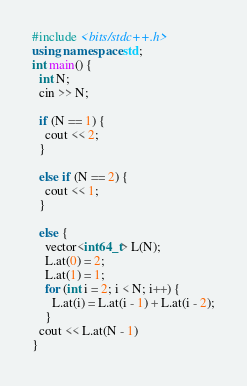Convert code to text. <code><loc_0><loc_0><loc_500><loc_500><_C++_>#include <bits/stdc++.h>
using namespace std;
int main() {
  int N;
  cin >> N;
 
  if (N == 1) {
    cout << 2;
  }
  
  else if (N == 2) {
    cout << 1;
  }
    
  else {
    vector<int64_t> L(N);
    L.at(0) = 2;
    L.at(1) = 1;
    for (int i = 2; i < N; i++) {
      L.at(i) = L.at(i - 1) + L.at(i - 2);
    }
  cout << L.at(N - 1)
}
</code> 